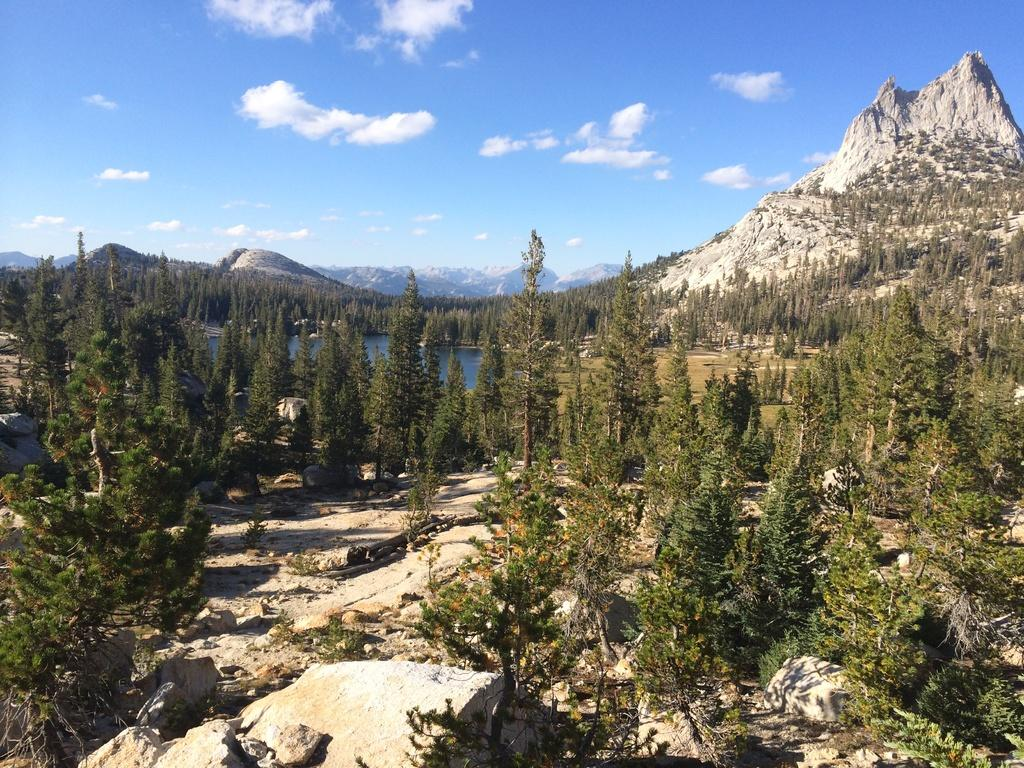What type of natural environment is depicted in the image? There is a surface with trees and plants in the image, suggesting a natural environment. What can be seen in the water in the image? The facts do not specify what can be seen in the water. What geological feature is present in the image? There is a mountain with a rock in the image. What is visible in the sky in the image? The sky is visible in the image, and clouds are present. How many books are stacked on the rock in the image? There are no books present in the image; it features a mountain with a rock and a natural environment. What color are the oranges on the trees in the image? There are no oranges present in the image; it features trees and plants, but no specific fruit is mentioned. 